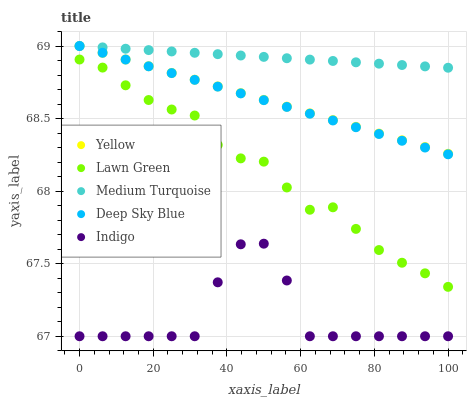Does Indigo have the minimum area under the curve?
Answer yes or no. Yes. Does Medium Turquoise have the maximum area under the curve?
Answer yes or no. Yes. Does Medium Turquoise have the minimum area under the curve?
Answer yes or no. No. Does Indigo have the maximum area under the curve?
Answer yes or no. No. Is Medium Turquoise the smoothest?
Answer yes or no. Yes. Is Indigo the roughest?
Answer yes or no. Yes. Is Indigo the smoothest?
Answer yes or no. No. Is Medium Turquoise the roughest?
Answer yes or no. No. Does Indigo have the lowest value?
Answer yes or no. Yes. Does Medium Turquoise have the lowest value?
Answer yes or no. No. Does Deep Sky Blue have the highest value?
Answer yes or no. Yes. Does Indigo have the highest value?
Answer yes or no. No. Is Indigo less than Medium Turquoise?
Answer yes or no. Yes. Is Yellow greater than Indigo?
Answer yes or no. Yes. Does Medium Turquoise intersect Yellow?
Answer yes or no. Yes. Is Medium Turquoise less than Yellow?
Answer yes or no. No. Is Medium Turquoise greater than Yellow?
Answer yes or no. No. Does Indigo intersect Medium Turquoise?
Answer yes or no. No. 